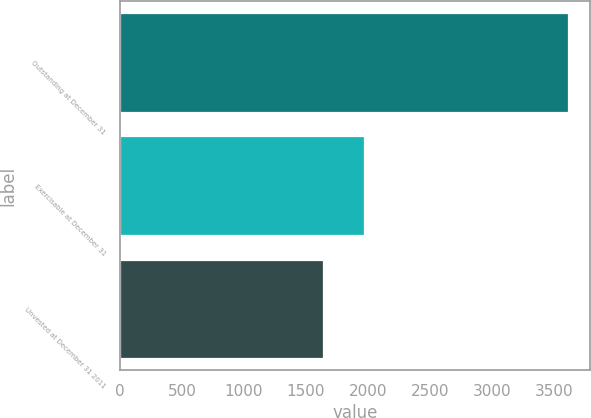<chart> <loc_0><loc_0><loc_500><loc_500><bar_chart><fcel>Outstanding at December 31<fcel>Exercisable at December 31<fcel>Unvested at December 31 2011<nl><fcel>3608<fcel>1968<fcel>1640<nl></chart> 